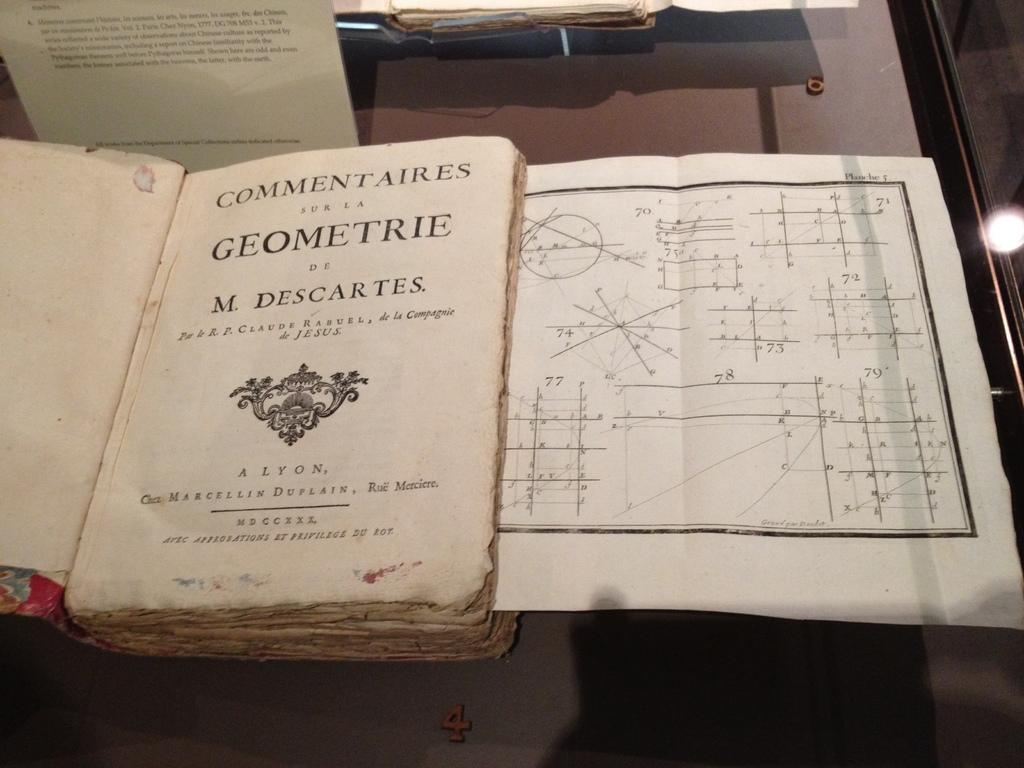<image>
Give a short and clear explanation of the subsequent image. An old book with the title Commentaires sur la Geometrie on it. 